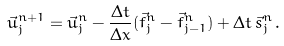Convert formula to latex. <formula><loc_0><loc_0><loc_500><loc_500>\vec { u } _ { j } ^ { n + 1 } = \vec { u } _ { j } ^ { n } - \frac { \Delta t } { \Delta x } ( \vec { f } _ { j } ^ { n } - \vec { f } _ { j - 1 } ^ { n } ) + \Delta t \, \vec { s } _ { j } ^ { n } \, .</formula> 